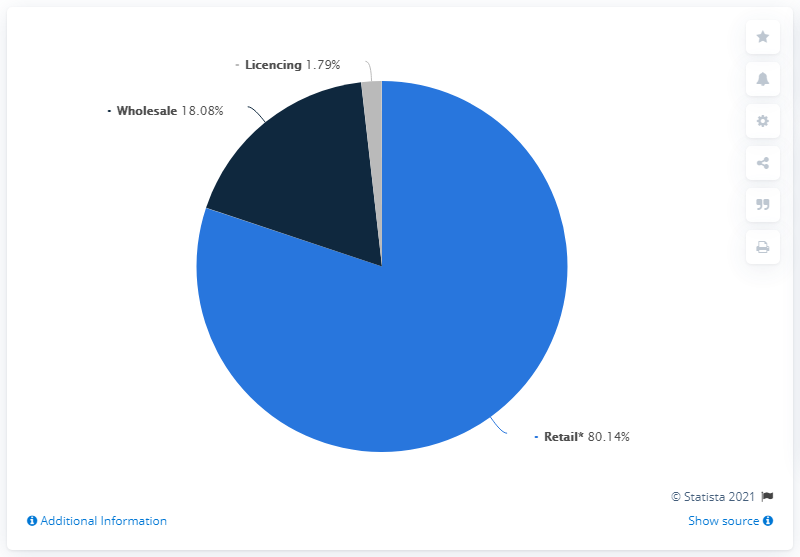Specify some key components in this picture. The revenue that has the highest share is retail. The sum of wholesale and licensing is 19.87. 